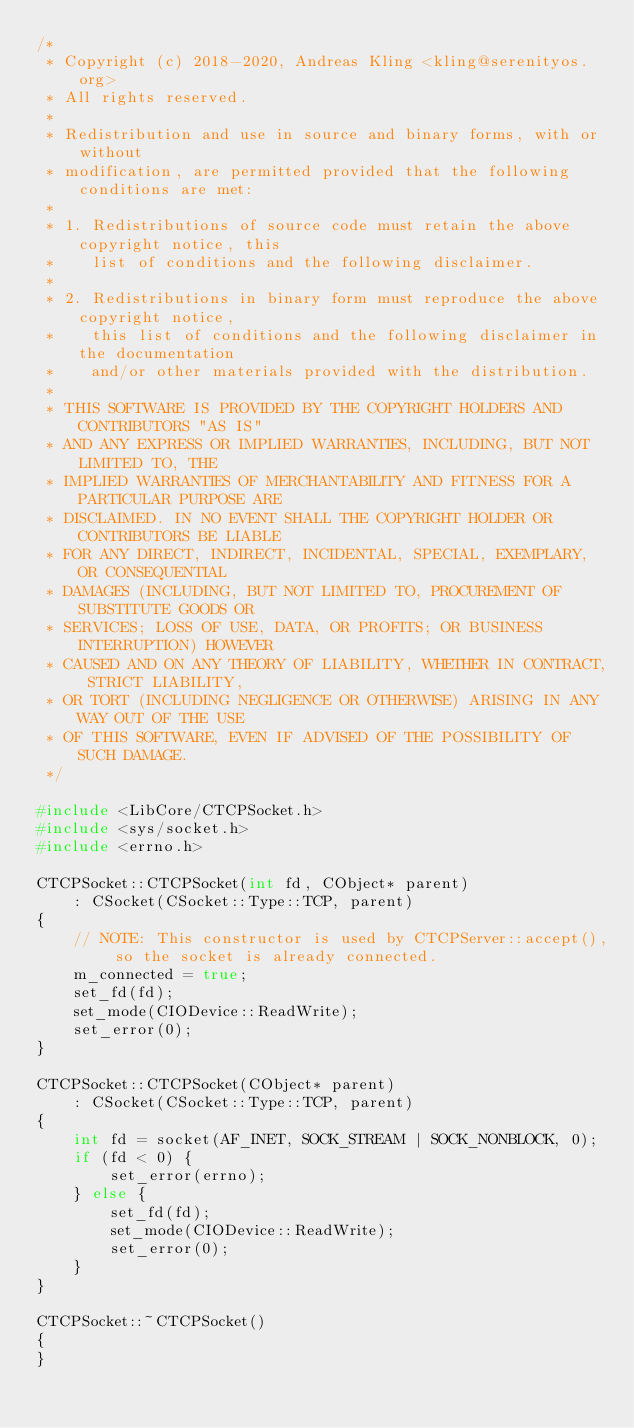<code> <loc_0><loc_0><loc_500><loc_500><_C++_>/*
 * Copyright (c) 2018-2020, Andreas Kling <kling@serenityos.org>
 * All rights reserved.
 *
 * Redistribution and use in source and binary forms, with or without
 * modification, are permitted provided that the following conditions are met:
 *
 * 1. Redistributions of source code must retain the above copyright notice, this
 *    list of conditions and the following disclaimer.
 *
 * 2. Redistributions in binary form must reproduce the above copyright notice,
 *    this list of conditions and the following disclaimer in the documentation
 *    and/or other materials provided with the distribution.
 *
 * THIS SOFTWARE IS PROVIDED BY THE COPYRIGHT HOLDERS AND CONTRIBUTORS "AS IS"
 * AND ANY EXPRESS OR IMPLIED WARRANTIES, INCLUDING, BUT NOT LIMITED TO, THE
 * IMPLIED WARRANTIES OF MERCHANTABILITY AND FITNESS FOR A PARTICULAR PURPOSE ARE
 * DISCLAIMED. IN NO EVENT SHALL THE COPYRIGHT HOLDER OR CONTRIBUTORS BE LIABLE
 * FOR ANY DIRECT, INDIRECT, INCIDENTAL, SPECIAL, EXEMPLARY, OR CONSEQUENTIAL
 * DAMAGES (INCLUDING, BUT NOT LIMITED TO, PROCUREMENT OF SUBSTITUTE GOODS OR
 * SERVICES; LOSS OF USE, DATA, OR PROFITS; OR BUSINESS INTERRUPTION) HOWEVER
 * CAUSED AND ON ANY THEORY OF LIABILITY, WHETHER IN CONTRACT, STRICT LIABILITY,
 * OR TORT (INCLUDING NEGLIGENCE OR OTHERWISE) ARISING IN ANY WAY OUT OF THE USE
 * OF THIS SOFTWARE, EVEN IF ADVISED OF THE POSSIBILITY OF SUCH DAMAGE.
 */

#include <LibCore/CTCPSocket.h>
#include <sys/socket.h>
#include <errno.h>

CTCPSocket::CTCPSocket(int fd, CObject* parent)
    : CSocket(CSocket::Type::TCP, parent)
{
    // NOTE: This constructor is used by CTCPServer::accept(), so the socket is already connected.
    m_connected = true;
    set_fd(fd);
    set_mode(CIODevice::ReadWrite);
    set_error(0);
}

CTCPSocket::CTCPSocket(CObject* parent)
    : CSocket(CSocket::Type::TCP, parent)
{
    int fd = socket(AF_INET, SOCK_STREAM | SOCK_NONBLOCK, 0);
    if (fd < 0) {
        set_error(errno);
    } else {
        set_fd(fd);
        set_mode(CIODevice::ReadWrite);
        set_error(0);
    }
}

CTCPSocket::~CTCPSocket()
{
}
</code> 